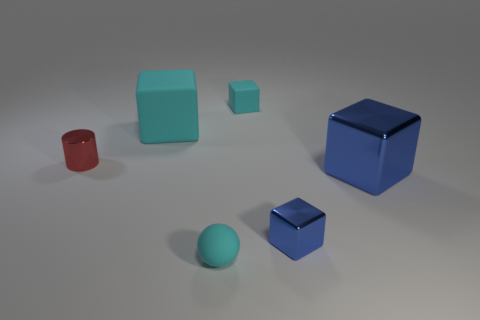Does the small blue shiny thing have the same shape as the red object?
Provide a short and direct response. No. Is there any other thing that has the same shape as the large blue metallic object?
Provide a succinct answer. Yes. Are the cyan thing that is behind the big cyan matte block and the big blue cube made of the same material?
Offer a very short reply. No. There is a thing that is both to the right of the small cyan rubber ball and behind the red shiny cylinder; what is its shape?
Offer a terse response. Cube. Are there any big blocks left of the tiny red cylinder left of the small blue metal object?
Provide a succinct answer. No. There is a small shiny thing right of the red cylinder; is it the same shape as the small cyan rubber object behind the big blue shiny block?
Your answer should be very brief. Yes. Does the large cyan block have the same material as the big blue object?
Provide a succinct answer. No. What is the size of the blue metal thing on the right side of the small metallic thing that is right of the small cyan object on the left side of the small rubber cube?
Your response must be concise. Large. How many other objects are the same color as the small sphere?
Provide a succinct answer. 2. What is the shape of the blue metallic thing that is the same size as the cyan ball?
Your response must be concise. Cube. 